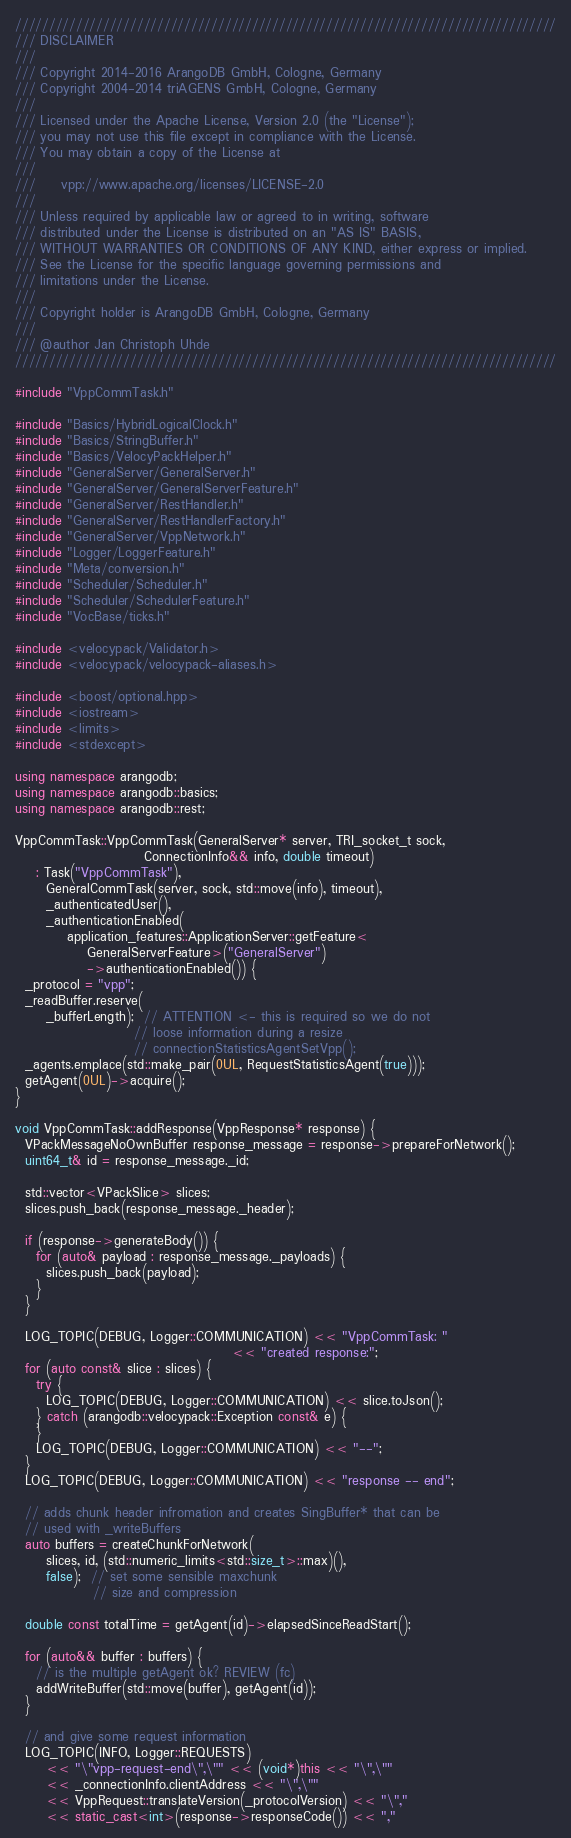Convert code to text. <code><loc_0><loc_0><loc_500><loc_500><_C++_>////////////////////////////////////////////////////////////////////////////////
/// DISCLAIMER
///
/// Copyright 2014-2016 ArangoDB GmbH, Cologne, Germany
/// Copyright 2004-2014 triAGENS GmbH, Cologne, Germany
///
/// Licensed under the Apache License, Version 2.0 (the "License");
/// you may not use this file except in compliance with the License.
/// You may obtain a copy of the License at
///
///     vpp://www.apache.org/licenses/LICENSE-2.0
///
/// Unless required by applicable law or agreed to in writing, software
/// distributed under the License is distributed on an "AS IS" BASIS,
/// WITHOUT WARRANTIES OR CONDITIONS OF ANY KIND, either express or implied.
/// See the License for the specific language governing permissions and
/// limitations under the License.
///
/// Copyright holder is ArangoDB GmbH, Cologne, Germany
///
/// @author Jan Christoph Uhde
////////////////////////////////////////////////////////////////////////////////

#include "VppCommTask.h"

#include "Basics/HybridLogicalClock.h"
#include "Basics/StringBuffer.h"
#include "Basics/VelocyPackHelper.h"
#include "GeneralServer/GeneralServer.h"
#include "GeneralServer/GeneralServerFeature.h"
#include "GeneralServer/RestHandler.h"
#include "GeneralServer/RestHandlerFactory.h"
#include "GeneralServer/VppNetwork.h"
#include "Logger/LoggerFeature.h"
#include "Meta/conversion.h"
#include "Scheduler/Scheduler.h"
#include "Scheduler/SchedulerFeature.h"
#include "VocBase/ticks.h"

#include <velocypack/Validator.h>
#include <velocypack/velocypack-aliases.h>

#include <boost/optional.hpp>
#include <iostream>
#include <limits>
#include <stdexcept>

using namespace arangodb;
using namespace arangodb::basics;
using namespace arangodb::rest;

VppCommTask::VppCommTask(GeneralServer* server, TRI_socket_t sock,
                         ConnectionInfo&& info, double timeout)
    : Task("VppCommTask"),
      GeneralCommTask(server, sock, std::move(info), timeout),
      _authenticatedUser(),
      _authenticationEnabled(
          application_features::ApplicationServer::getFeature<
              GeneralServerFeature>("GeneralServer")
              ->authenticationEnabled()) {
  _protocol = "vpp";
  _readBuffer.reserve(
      _bufferLength);  // ATTENTION <- this is required so we do not
                       // loose information during a resize
                       // connectionStatisticsAgentSetVpp();
  _agents.emplace(std::make_pair(0UL, RequestStatisticsAgent(true)));
  getAgent(0UL)->acquire();
}

void VppCommTask::addResponse(VppResponse* response) {
  VPackMessageNoOwnBuffer response_message = response->prepareForNetwork();
  uint64_t& id = response_message._id;

  std::vector<VPackSlice> slices;
  slices.push_back(response_message._header);

  if (response->generateBody()) {
    for (auto& payload : response_message._payloads) {
      slices.push_back(payload);
    }
  }

  LOG_TOPIC(DEBUG, Logger::COMMUNICATION) << "VppCommTask: "
                                          << "created response:";
  for (auto const& slice : slices) {
    try {
      LOG_TOPIC(DEBUG, Logger::COMMUNICATION) << slice.toJson();
    } catch (arangodb::velocypack::Exception const& e) {
    }
    LOG_TOPIC(DEBUG, Logger::COMMUNICATION) << "--";
  }
  LOG_TOPIC(DEBUG, Logger::COMMUNICATION) << "response -- end";

  // adds chunk header infromation and creates SingBuffer* that can be
  // used with _writeBuffers
  auto buffers = createChunkForNetwork(
      slices, id, (std::numeric_limits<std::size_t>::max)(),
      false);  // set some sensible maxchunk
               // size and compression

  double const totalTime = getAgent(id)->elapsedSinceReadStart();

  for (auto&& buffer : buffers) {
    // is the multiple getAgent ok? REVIEW (fc)
    addWriteBuffer(std::move(buffer), getAgent(id));
  }

  // and give some request information
  LOG_TOPIC(INFO, Logger::REQUESTS)
      << "\"vpp-request-end\",\"" << (void*)this << "\",\""
      << _connectionInfo.clientAddress << "\",\""
      << VppRequest::translateVersion(_protocolVersion) << "\","
      << static_cast<int>(response->responseCode()) << ","</code> 